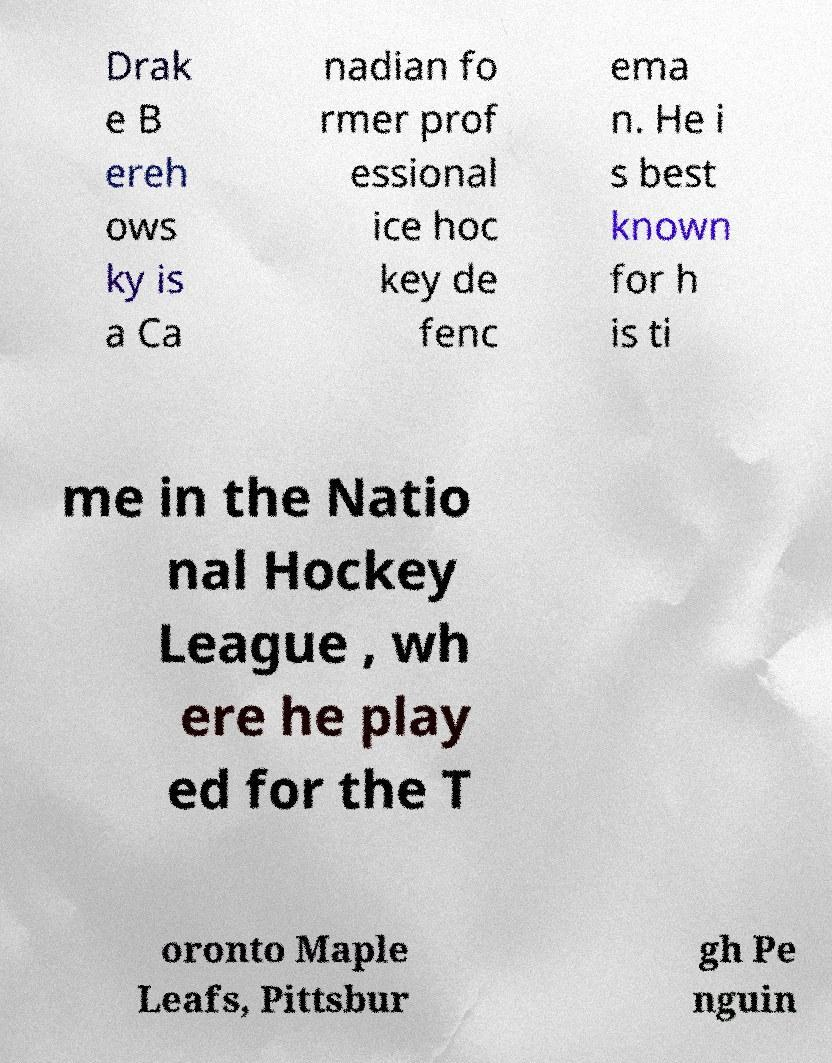I need the written content from this picture converted into text. Can you do that? Drak e B ereh ows ky is a Ca nadian fo rmer prof essional ice hoc key de fenc ema n. He i s best known for h is ti me in the Natio nal Hockey League , wh ere he play ed for the T oronto Maple Leafs, Pittsbur gh Pe nguin 